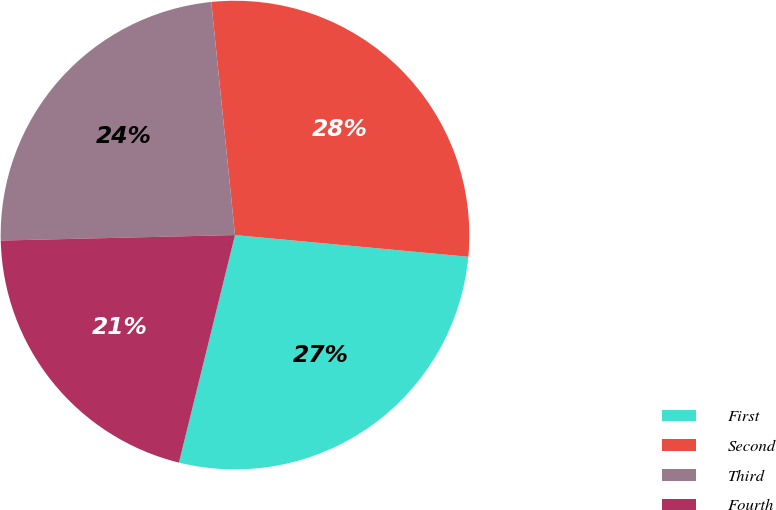Convert chart. <chart><loc_0><loc_0><loc_500><loc_500><pie_chart><fcel>First<fcel>Second<fcel>Third<fcel>Fourth<nl><fcel>27.37%<fcel>28.09%<fcel>23.76%<fcel>20.78%<nl></chart> 